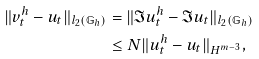Convert formula to latex. <formula><loc_0><loc_0><loc_500><loc_500>\| v ^ { h } _ { t } - u _ { t } \| _ { l _ { 2 } ( \mathbb { G } _ { h } ) } & = \| \mathfrak { I } u ^ { h } _ { t } - \mathfrak { I } u _ { t } \| _ { l _ { 2 } ( \mathbb { G } _ { h } ) } \\ & \leq N \| u ^ { h } _ { t } - u _ { t } \| _ { H ^ { m - 3 } } ,</formula> 